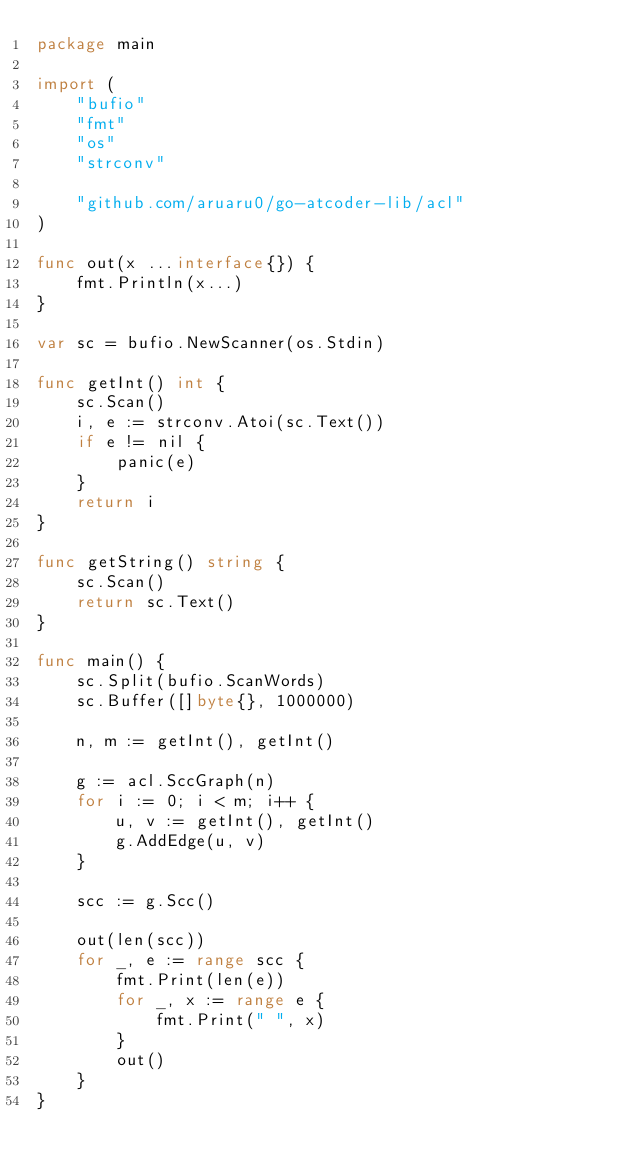<code> <loc_0><loc_0><loc_500><loc_500><_Go_>package main

import (
	"bufio"
	"fmt"
	"os"
	"strconv"

	"github.com/aruaru0/go-atcoder-lib/acl"
)

func out(x ...interface{}) {
	fmt.Println(x...)
}

var sc = bufio.NewScanner(os.Stdin)

func getInt() int {
	sc.Scan()
	i, e := strconv.Atoi(sc.Text())
	if e != nil {
		panic(e)
	}
	return i
}

func getString() string {
	sc.Scan()
	return sc.Text()
}

func main() {
	sc.Split(bufio.ScanWords)
	sc.Buffer([]byte{}, 1000000)

	n, m := getInt(), getInt()

	g := acl.SccGraph(n)
	for i := 0; i < m; i++ {
		u, v := getInt(), getInt()
		g.AddEdge(u, v)
	}

	scc := g.Scc()

	out(len(scc))
	for _, e := range scc {
		fmt.Print(len(e))
		for _, x := range e {
			fmt.Print(" ", x)
		}
		out()
	}
}
</code> 